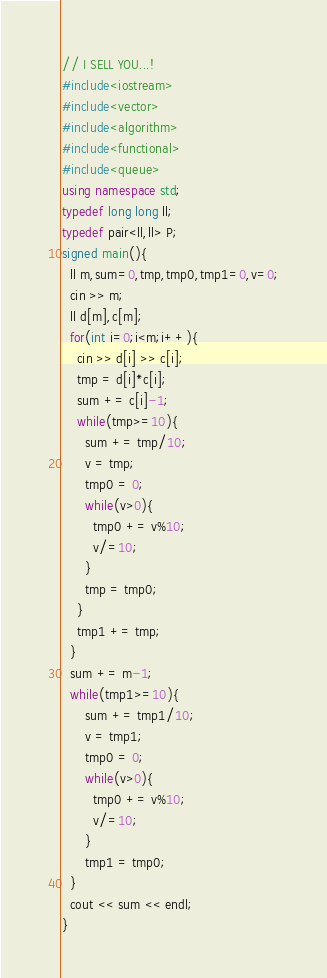<code> <loc_0><loc_0><loc_500><loc_500><_C++_>// I SELL YOU...! 
#include<iostream>
#include<vector>
#include<algorithm>
#include<functional>
#include<queue>
using namespace std;
typedef long long ll;
typedef pair<ll,ll> P;
signed main(){
  ll m,sum=0,tmp,tmp0,tmp1=0,v=0;
  cin >> m;
  ll d[m],c[m];
  for(int i=0;i<m;i++){
    cin >> d[i] >> c[i];
    tmp = d[i]*c[i];
    sum += c[i]-1;
    while(tmp>=10){
      sum += tmp/10;
      v = tmp;
      tmp0 = 0;
      while(v>0){
        tmp0 += v%10;
        v/=10;
      }
      tmp = tmp0;
    }
    tmp1 += tmp;
  }
  sum += m-1;
  while(tmp1>=10){
      sum += tmp1/10;
      v = tmp1;
      tmp0 = 0;
      while(v>0){
        tmp0 += v%10;
        v/=10;
      }
      tmp1 = tmp0;
  }
  cout << sum << endl;
}
</code> 